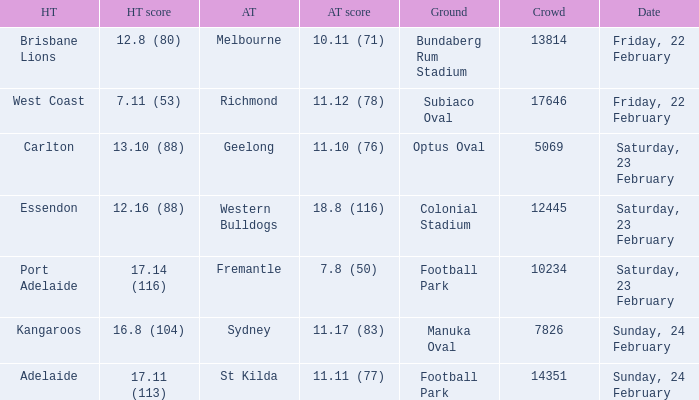What score did the away team receive against home team Port Adelaide? 7.8 (50). 